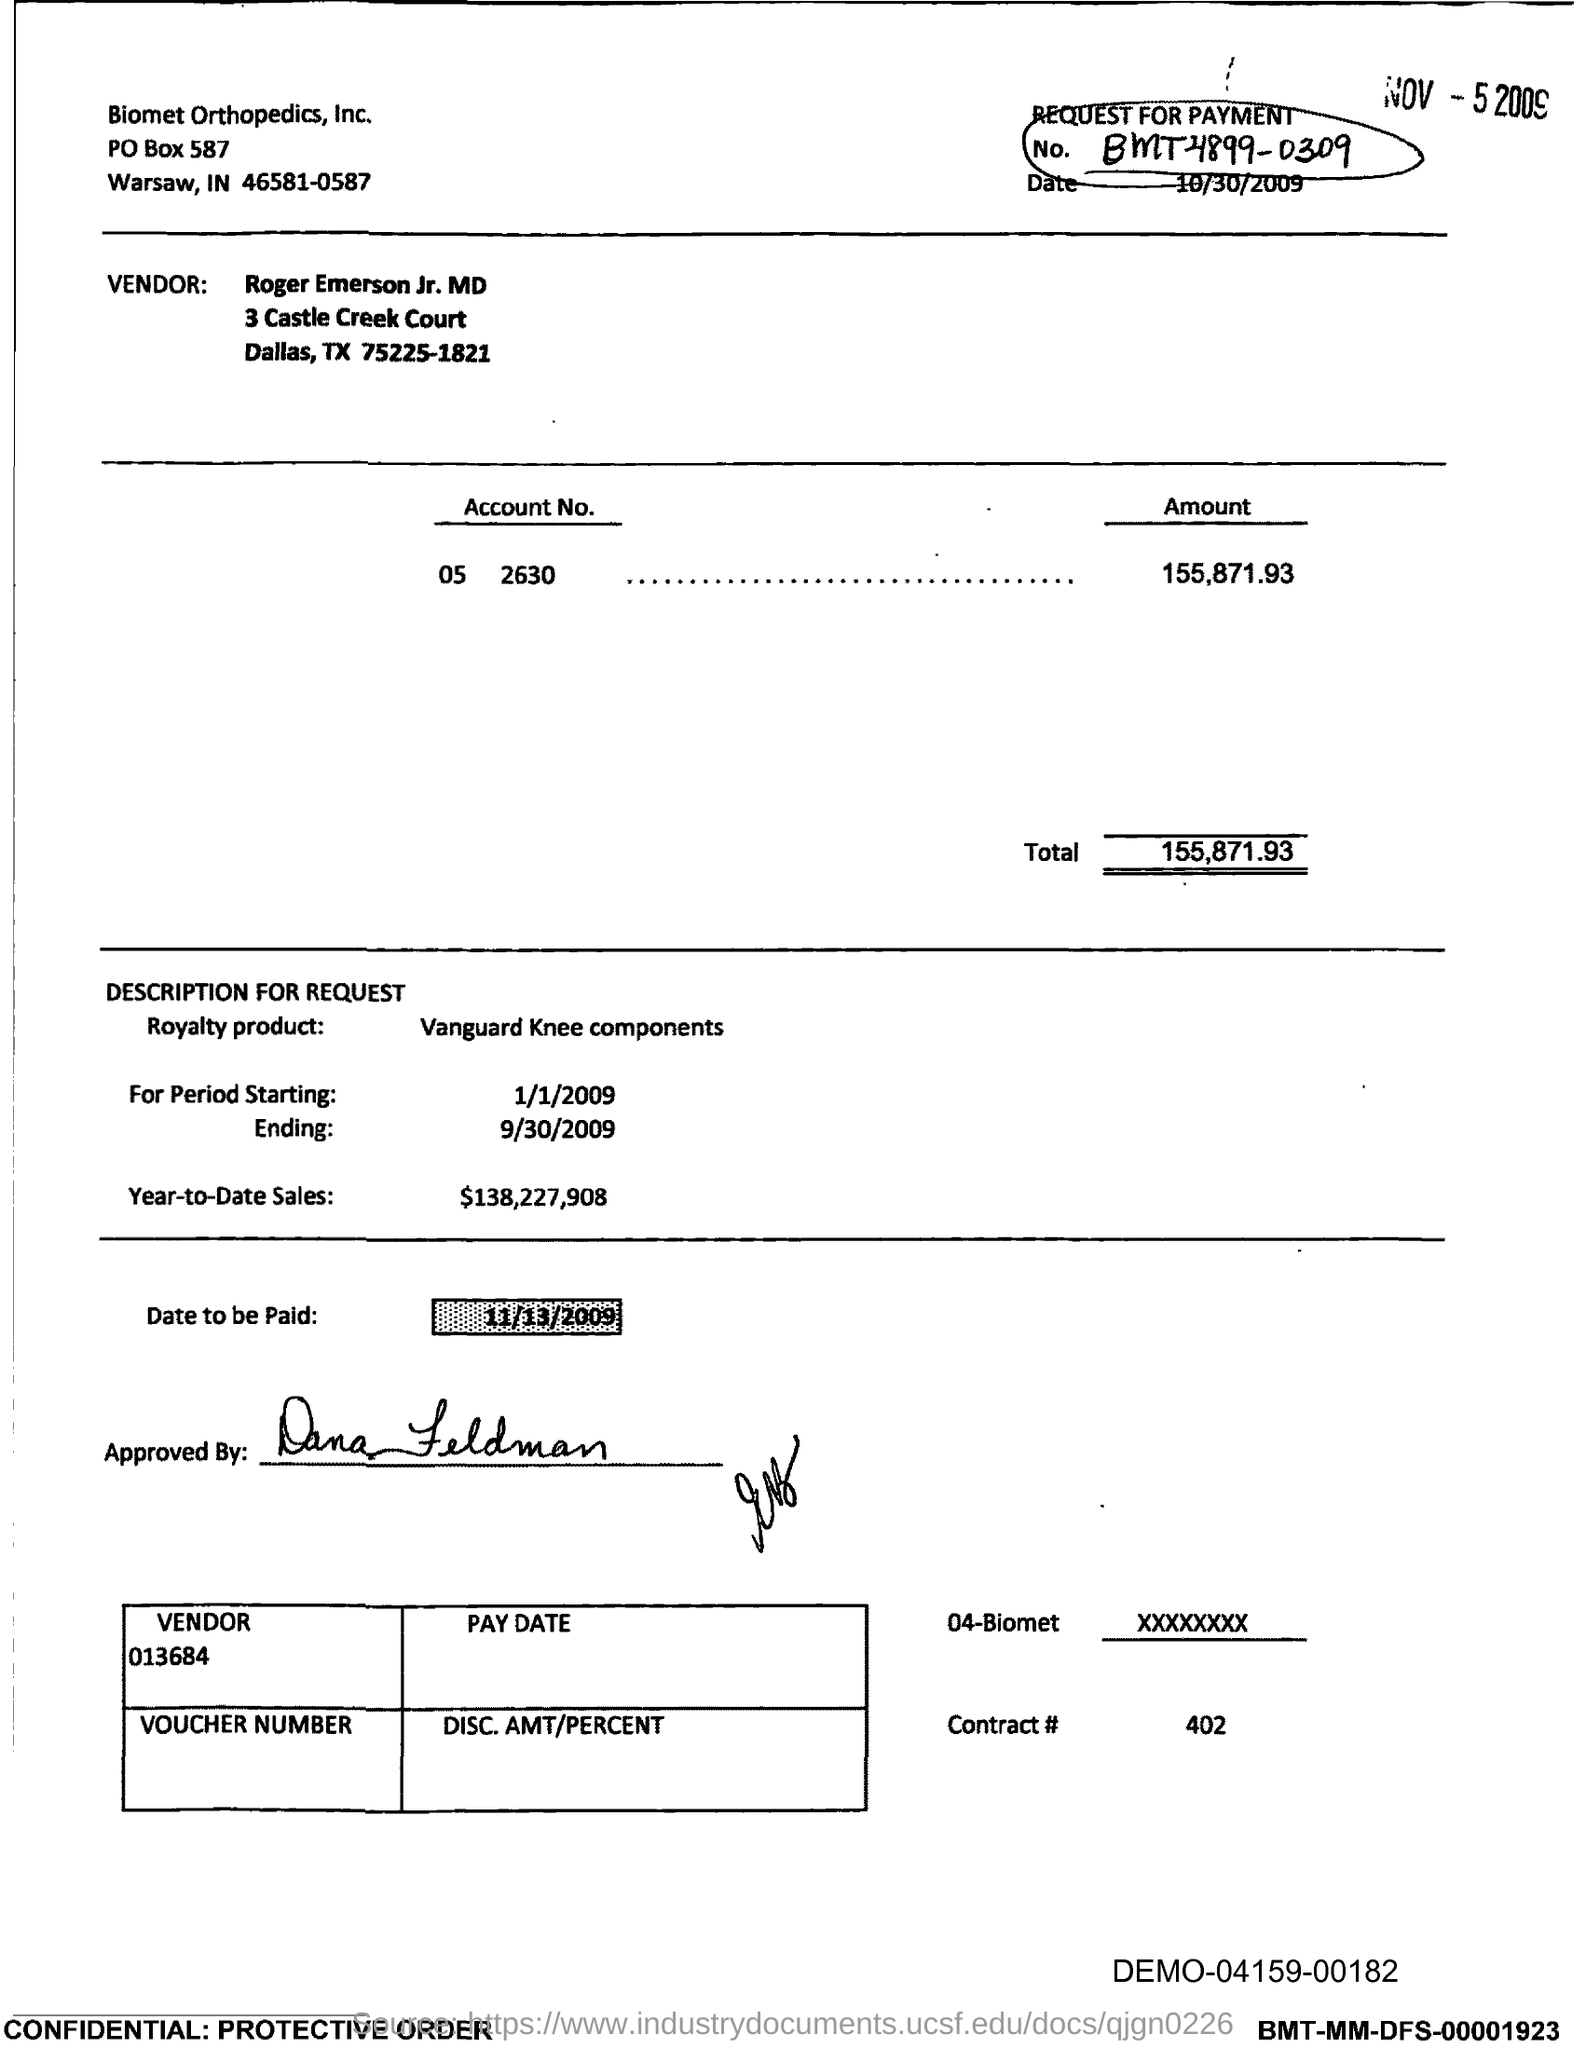What is the no. circled at the top right corner?
Make the answer very short. BMT-4899-0309. How much is the total amount?
Your response must be concise. 155,871.93. What is the royalty product?
Make the answer very short. Vanguard knee components. What is the date to be paid?
Give a very brief answer. 11/13/2009. What is the street address of the vendor?
Ensure brevity in your answer.  3 Castle creek Court. What is the date stamped at the top right corner?
Your answer should be very brief. Nov-5 2009. Who has approved it?
Provide a short and direct response. Dana Feldman. What is the post box number of biomet orthopedics, inc.?
Keep it short and to the point. 587. What is the period ending date?
Give a very brief answer. 9/30/2009. 